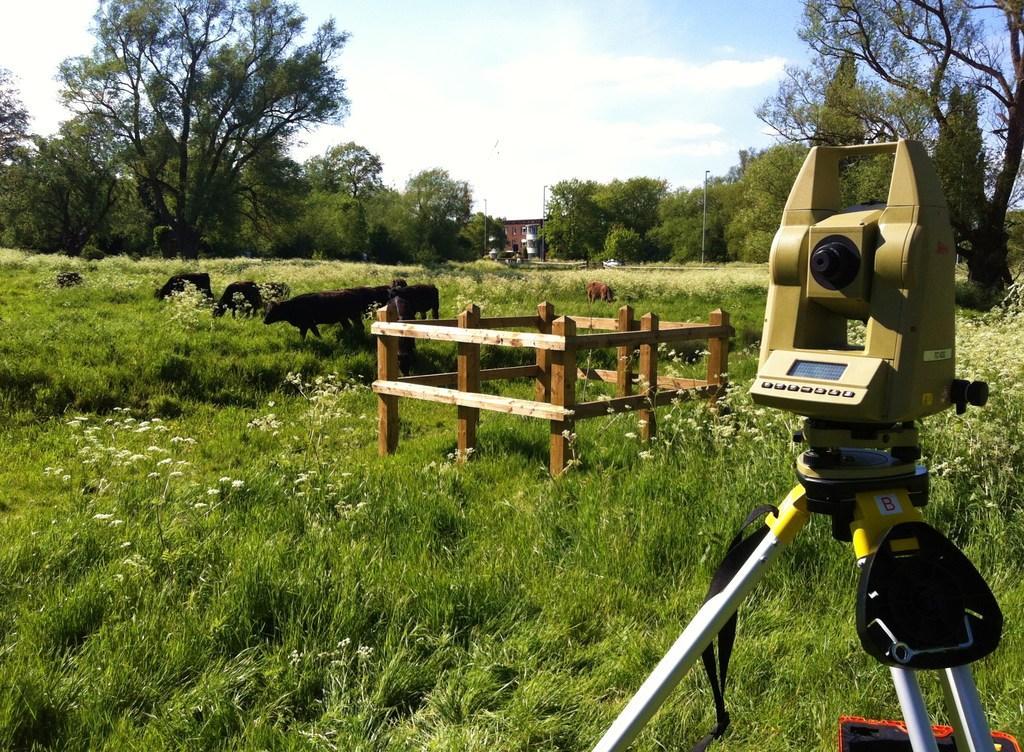Could you give a brief overview of what you see in this image? In this picture we can observe a camera tool used by the civil engineer for surveying which fixed to the tripod stand. There is a wooden railing. We can observe some grass and animals on the ground. In the background there are trees and a sky with some clouds. 